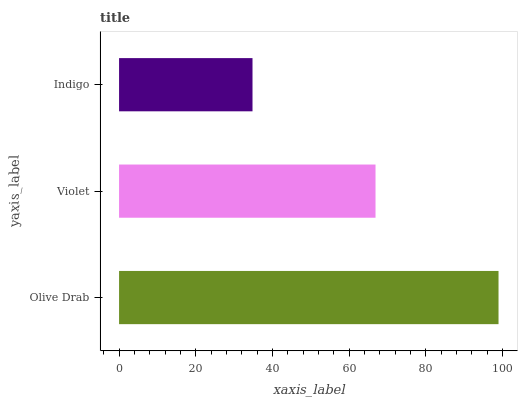Is Indigo the minimum?
Answer yes or no. Yes. Is Olive Drab the maximum?
Answer yes or no. Yes. Is Violet the minimum?
Answer yes or no. No. Is Violet the maximum?
Answer yes or no. No. Is Olive Drab greater than Violet?
Answer yes or no. Yes. Is Violet less than Olive Drab?
Answer yes or no. Yes. Is Violet greater than Olive Drab?
Answer yes or no. No. Is Olive Drab less than Violet?
Answer yes or no. No. Is Violet the high median?
Answer yes or no. Yes. Is Violet the low median?
Answer yes or no. Yes. Is Indigo the high median?
Answer yes or no. No. Is Olive Drab the low median?
Answer yes or no. No. 